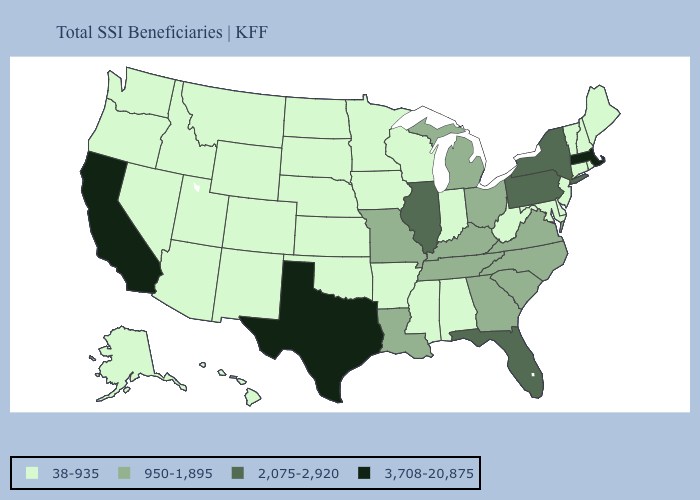Name the states that have a value in the range 3,708-20,875?
Answer briefly. California, Massachusetts, Texas. Does Michigan have the lowest value in the MidWest?
Be succinct. No. Name the states that have a value in the range 38-935?
Keep it brief. Alabama, Alaska, Arizona, Arkansas, Colorado, Connecticut, Delaware, Hawaii, Idaho, Indiana, Iowa, Kansas, Maine, Maryland, Minnesota, Mississippi, Montana, Nebraska, Nevada, New Hampshire, New Jersey, New Mexico, North Dakota, Oklahoma, Oregon, Rhode Island, South Dakota, Utah, Vermont, Washington, West Virginia, Wisconsin, Wyoming. Which states have the lowest value in the South?
Be succinct. Alabama, Arkansas, Delaware, Maryland, Mississippi, Oklahoma, West Virginia. Among the states that border Iowa , does Wisconsin have the lowest value?
Quick response, please. Yes. Does New Jersey have the lowest value in the Northeast?
Quick response, please. Yes. Which states have the lowest value in the USA?
Keep it brief. Alabama, Alaska, Arizona, Arkansas, Colorado, Connecticut, Delaware, Hawaii, Idaho, Indiana, Iowa, Kansas, Maine, Maryland, Minnesota, Mississippi, Montana, Nebraska, Nevada, New Hampshire, New Jersey, New Mexico, North Dakota, Oklahoma, Oregon, Rhode Island, South Dakota, Utah, Vermont, Washington, West Virginia, Wisconsin, Wyoming. Name the states that have a value in the range 950-1,895?
Answer briefly. Georgia, Kentucky, Louisiana, Michigan, Missouri, North Carolina, Ohio, South Carolina, Tennessee, Virginia. Does California have the lowest value in the USA?
Give a very brief answer. No. What is the value of Massachusetts?
Write a very short answer. 3,708-20,875. What is the value of Rhode Island?
Give a very brief answer. 38-935. Name the states that have a value in the range 2,075-2,920?
Short answer required. Florida, Illinois, New York, Pennsylvania. Is the legend a continuous bar?
Keep it brief. No. Name the states that have a value in the range 950-1,895?
Quick response, please. Georgia, Kentucky, Louisiana, Michigan, Missouri, North Carolina, Ohio, South Carolina, Tennessee, Virginia. Does Idaho have the lowest value in the West?
Answer briefly. Yes. 